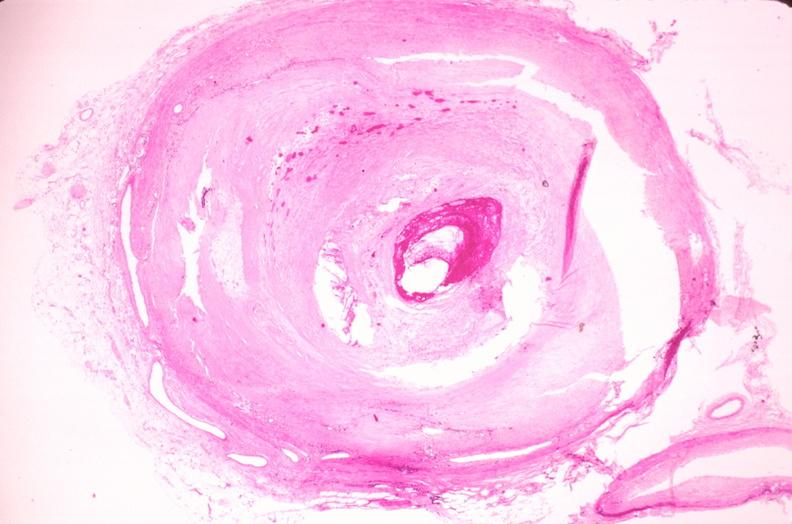s peritoneum present?
Answer the question using a single word or phrase. No 